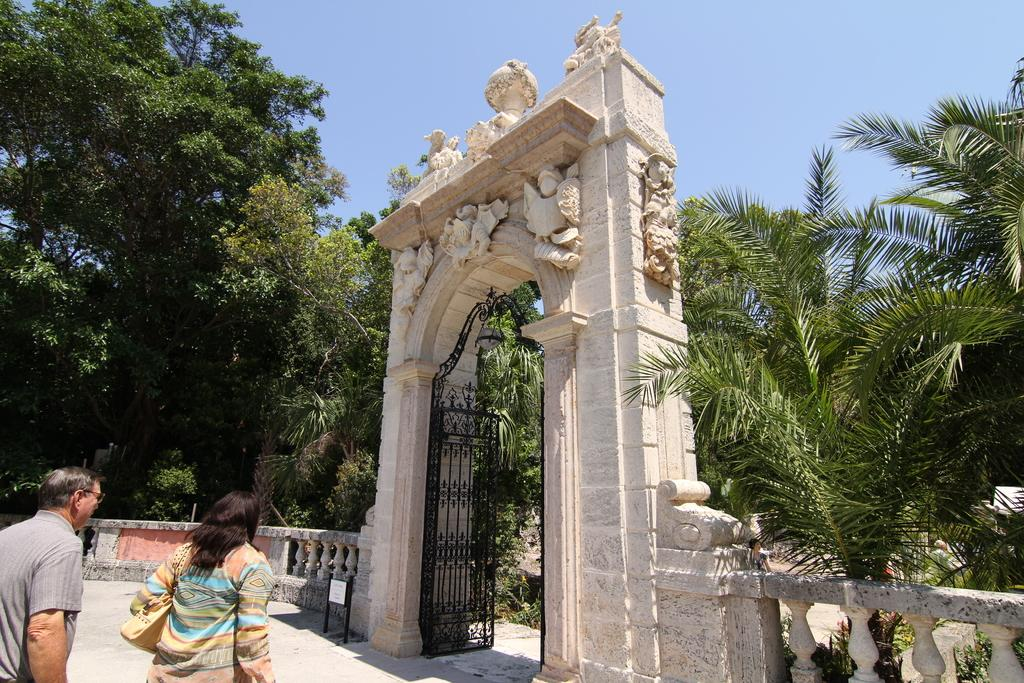How many people are in the image? There are two people in the image. What is one of the people carrying? One of the people, a woman, is carrying a bag. What can be seen in the image besides the people? There is a name board, an arch with sculptures, a gate, a fence, trees, and the sky visible in the background of the image. What type of frame is around the picture in the image? There is no picture or frame present in the image; it features two people, a name board, an arch, a gate, a fence, trees, and the sky. 